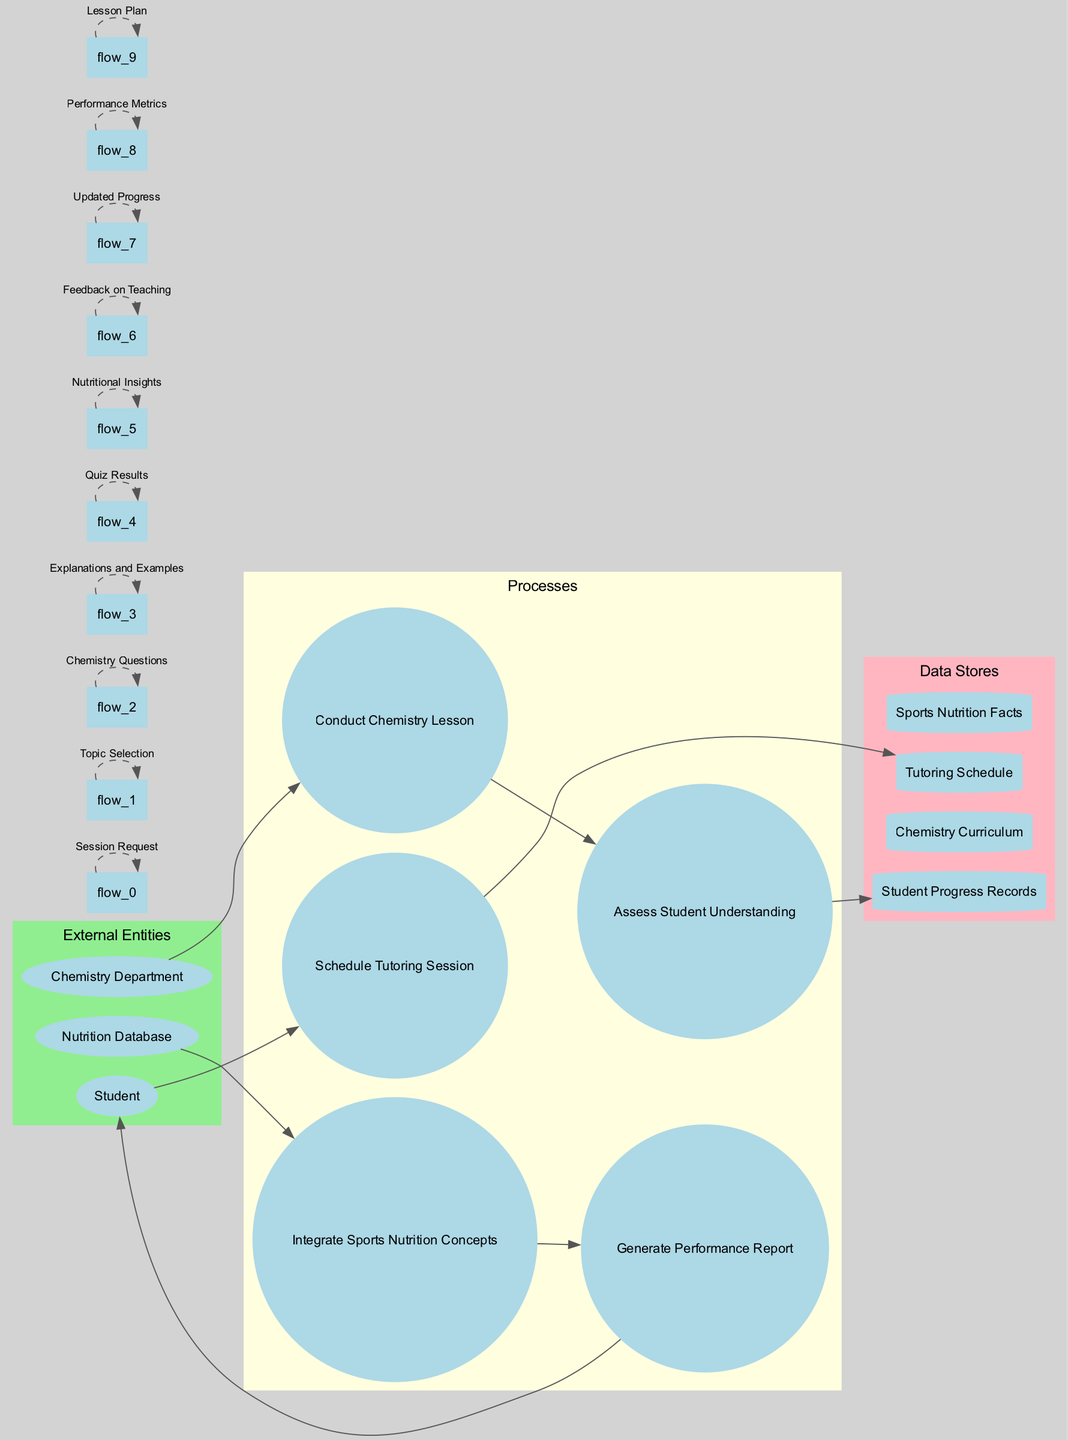What are the external entities in the diagram? The external entities are specifically labeled in the diagram and include "Student," "Chemistry Department," and "Nutrition Database." These are depicted as ellipses.
Answer: Student, Chemistry Department, Nutrition Database How many processes are listed in the diagram? The number of processes can be counted by identifying each distinct process represented in circular shapes in the diagram. These include five processes: "Schedule Tutoring Session," "Conduct Chemistry Lesson," "Assess Student Understanding," "Integrate Sports Nutrition Concepts," and "Generate Performance Report."
Answer: 5 Which data store is associated with student progress? The data store associated with student progress is explicitly labeled as "Student Progress Records" in the diagram. This represents a storage area for student-related data.
Answer: Student Progress Records What is the flow of data from the Chemistry Department? The data flow begins with the Chemistry Department leading to the process "Conduct Chemistry Lesson." This indicates the initiation of lesson activities based on requests from the Chemistry Department.
Answer: Conduct Chemistry Lesson What is the last process before feedback is generated? To determine the last process before feedback, one must follow the data flow leading to "Generate Performance Report," which processes the data collected to produce feedback for the students.
Answer: Generate Performance Report Which external entity sends a session request? The external entity that sends a "Session Request" is the "Student," which initiates the tutoring session management process in the diagram.
Answer: Student How many data flows are depicted in the diagram? To answer this, one counts all arrows representing data flows, which connect various processes and data stores. There are ten data flows indicated in the diagram.
Answer: 10 Which process integrates ideas from the Nutrition Database? The process that integrates ideas from the Nutrition Database is labeled as "Integrate Sports Nutrition Concepts." This shows the interaction between sports nutrition insights and the tutoring processes.
Answer: Integrate Sports Nutrition Concepts What is the purpose of "Assess Student Understanding"? This process evaluates the knowledge level of students based on their grasp of chemistry lessons, which is essential for tailoring further instruction to their needs.
Answer: Evaluate knowledge level 